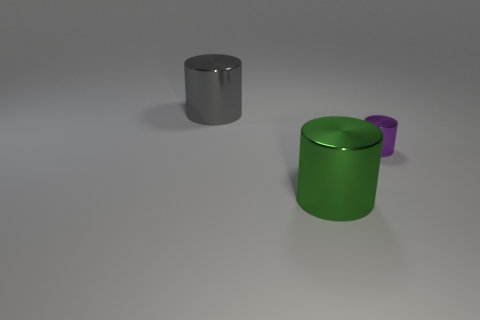Add 2 gray objects. How many objects exist? 5 Add 3 large gray cylinders. How many large gray cylinders are left? 4 Add 2 tiny gray metallic objects. How many tiny gray metallic objects exist? 2 Subtract 0 blue spheres. How many objects are left? 3 Subtract all gray things. Subtract all large green shiny cylinders. How many objects are left? 1 